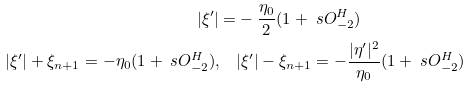Convert formula to latex. <formula><loc_0><loc_0><loc_500><loc_500>| \xi ^ { \prime } | = & - \frac { \eta _ { 0 } } { 2 } ( 1 + \ s O _ { - 2 } ^ { H } ) \\ | \xi ^ { \prime } | + \xi _ { n + 1 } = - \eta _ { 0 } ( 1 + \ s O _ { - 2 } ^ { H } ) , \quad & | \xi ^ { \prime } | - \xi _ { n + 1 } = - \frac { | \eta ^ { \prime } | ^ { 2 } } { \eta _ { 0 } } ( 1 + \ s O _ { - 2 } ^ { H } )</formula> 